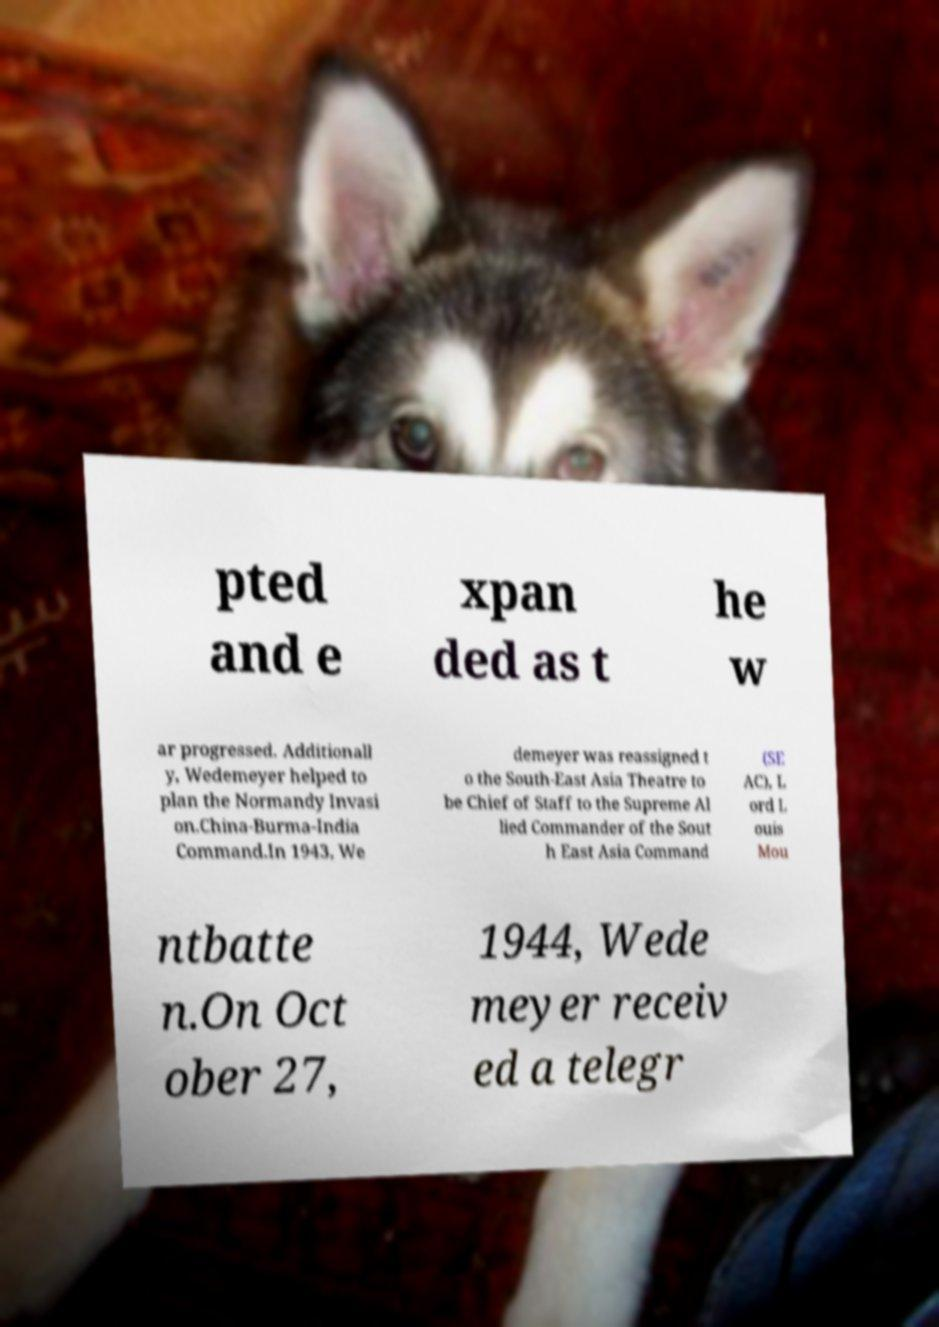For documentation purposes, I need the text within this image transcribed. Could you provide that? pted and e xpan ded as t he w ar progressed. Additionall y, Wedemeyer helped to plan the Normandy Invasi on.China-Burma-India Command.In 1943, We demeyer was reassigned t o the South-East Asia Theatre to be Chief of Staff to the Supreme Al lied Commander of the Sout h East Asia Command (SE AC), L ord L ouis Mou ntbatte n.On Oct ober 27, 1944, Wede meyer receiv ed a telegr 